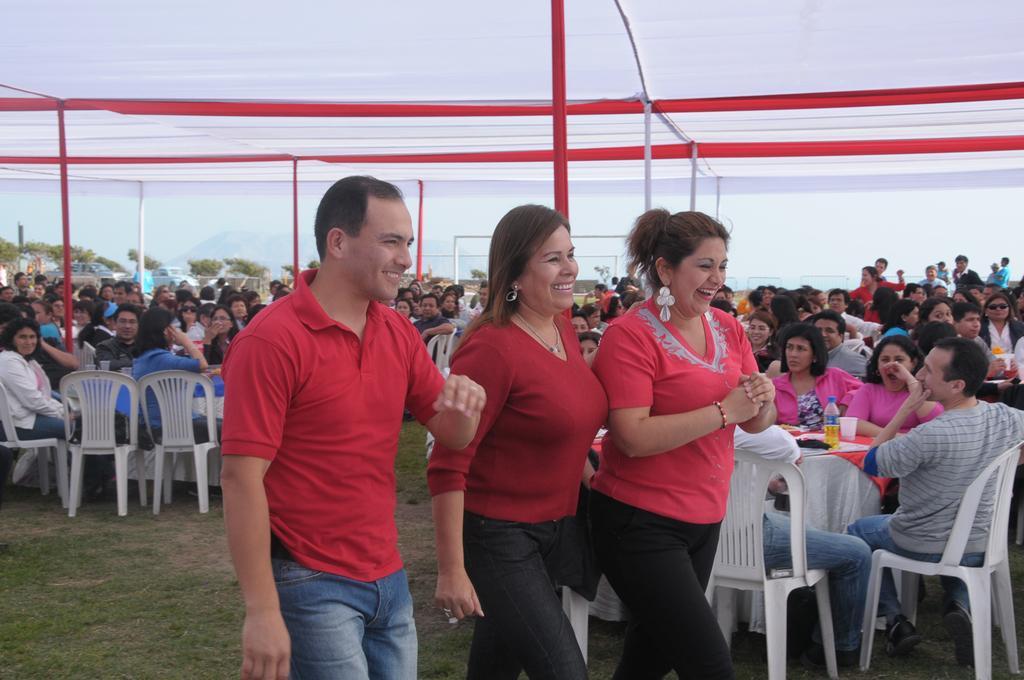Describe this image in one or two sentences. In the image there are three people walking to the right side,in the background there are some other people sitting,the people who are walking are wearing red dress two of them are women and one man,in the background there is sky and some trees and vehicles. 